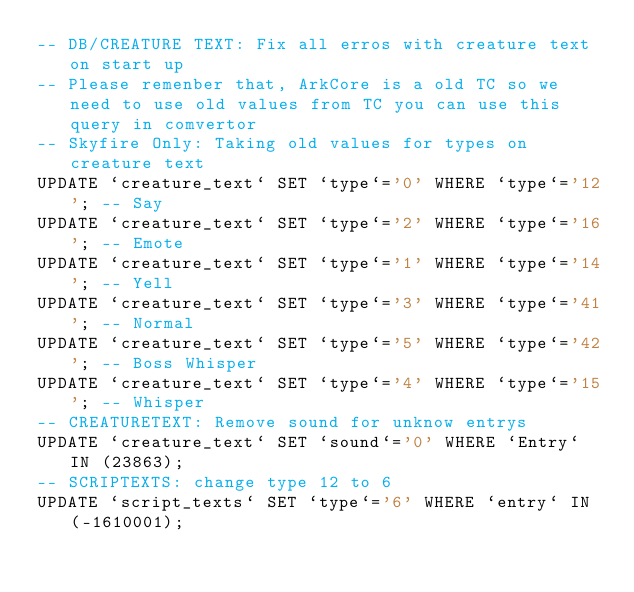<code> <loc_0><loc_0><loc_500><loc_500><_SQL_>-- DB/CREATURE TEXT: Fix all erros with creature text on start up
-- Please remenber that, ArkCore is a old TC so we need to use old values from TC you can use this query in comvertor
-- Skyfire Only: Taking old values for types on creature text
UPDATE `creature_text` SET `type`='0' WHERE `type`='12'; -- Say
UPDATE `creature_text` SET `type`='2' WHERE `type`='16'; -- Emote
UPDATE `creature_text` SET `type`='1' WHERE `type`='14'; -- Yell
UPDATE `creature_text` SET `type`='3' WHERE `type`='41'; -- Normal
UPDATE `creature_text` SET `type`='5' WHERE `type`='42'; -- Boss Whisper 
UPDATE `creature_text` SET `type`='4' WHERE `type`='15'; -- Whisper
-- CREATURETEXT: Remove sound for unknow entrys
UPDATE `creature_text` SET `sound`='0' WHERE `Entry` IN (23863);
-- SCRIPTEXTS: change type 12 to 6
UPDATE `script_texts` SET `type`='6' WHERE `entry` IN (-1610001);</code> 